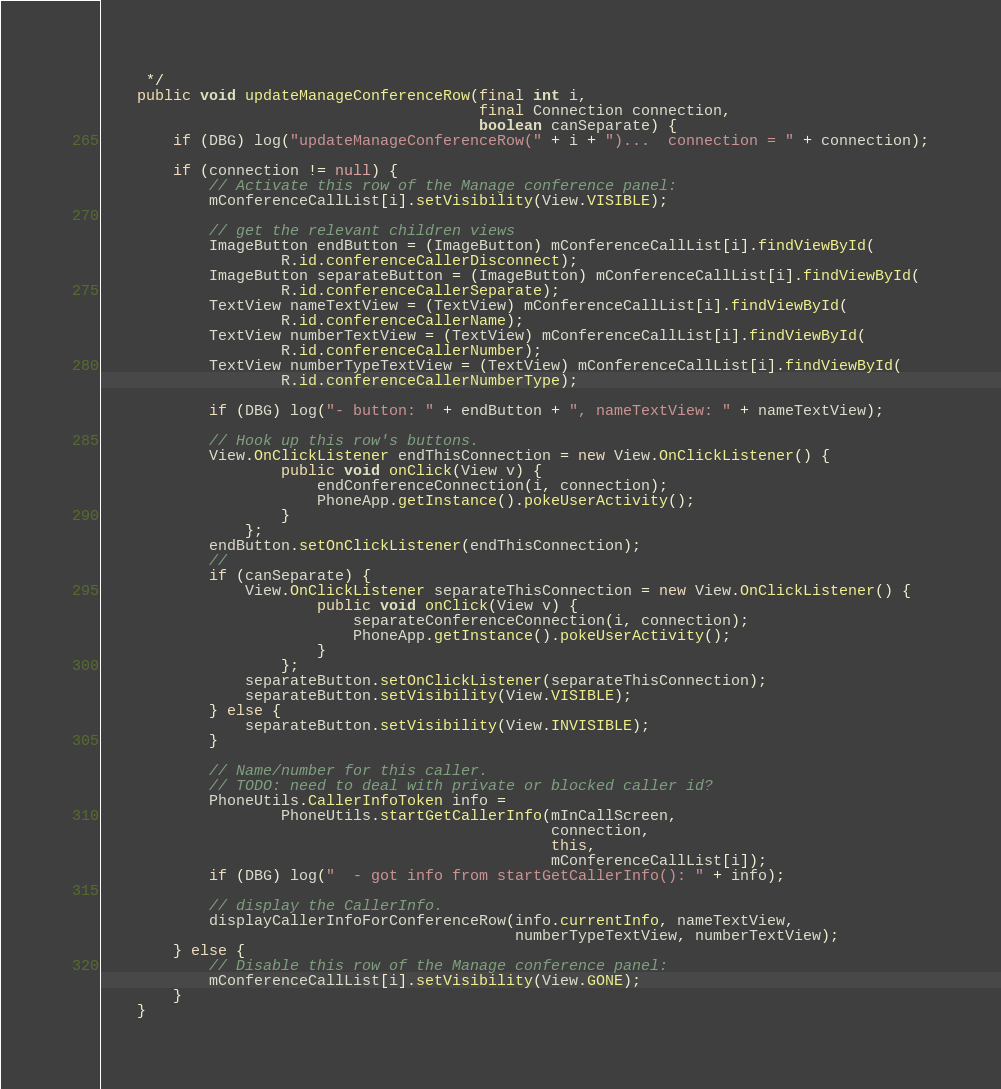<code> <loc_0><loc_0><loc_500><loc_500><_Java_>     */
    public void updateManageConferenceRow(final int i,
                                          final Connection connection,
                                          boolean canSeparate) {
        if (DBG) log("updateManageConferenceRow(" + i + ")...  connection = " + connection);

        if (connection != null) {
            // Activate this row of the Manage conference panel:
            mConferenceCallList[i].setVisibility(View.VISIBLE);

            // get the relevant children views
            ImageButton endButton = (ImageButton) mConferenceCallList[i].findViewById(
                    R.id.conferenceCallerDisconnect);
            ImageButton separateButton = (ImageButton) mConferenceCallList[i].findViewById(
                    R.id.conferenceCallerSeparate);
            TextView nameTextView = (TextView) mConferenceCallList[i].findViewById(
                    R.id.conferenceCallerName);
            TextView numberTextView = (TextView) mConferenceCallList[i].findViewById(
                    R.id.conferenceCallerNumber);
            TextView numberTypeTextView = (TextView) mConferenceCallList[i].findViewById(
                    R.id.conferenceCallerNumberType);

            if (DBG) log("- button: " + endButton + ", nameTextView: " + nameTextView);

            // Hook up this row's buttons.
            View.OnClickListener endThisConnection = new View.OnClickListener() {
                    public void onClick(View v) {
                        endConferenceConnection(i, connection);
                        PhoneApp.getInstance().pokeUserActivity();
                    }
                };
            endButton.setOnClickListener(endThisConnection);
            //
            if (canSeparate) {
                View.OnClickListener separateThisConnection = new View.OnClickListener() {
                        public void onClick(View v) {
                            separateConferenceConnection(i, connection);
                            PhoneApp.getInstance().pokeUserActivity();
                        }
                    };
                separateButton.setOnClickListener(separateThisConnection);
                separateButton.setVisibility(View.VISIBLE);
            } else {
                separateButton.setVisibility(View.INVISIBLE);
            }

            // Name/number for this caller.
            // TODO: need to deal with private or blocked caller id?
            PhoneUtils.CallerInfoToken info =
                    PhoneUtils.startGetCallerInfo(mInCallScreen,
                                                  connection,
                                                  this,
                                                  mConferenceCallList[i]);
            if (DBG) log("  - got info from startGetCallerInfo(): " + info);

            // display the CallerInfo.
            displayCallerInfoForConferenceRow(info.currentInfo, nameTextView,
                                              numberTypeTextView, numberTextView);
        } else {
            // Disable this row of the Manage conference panel:
            mConferenceCallList[i].setVisibility(View.GONE);
        }
    }
</code> 